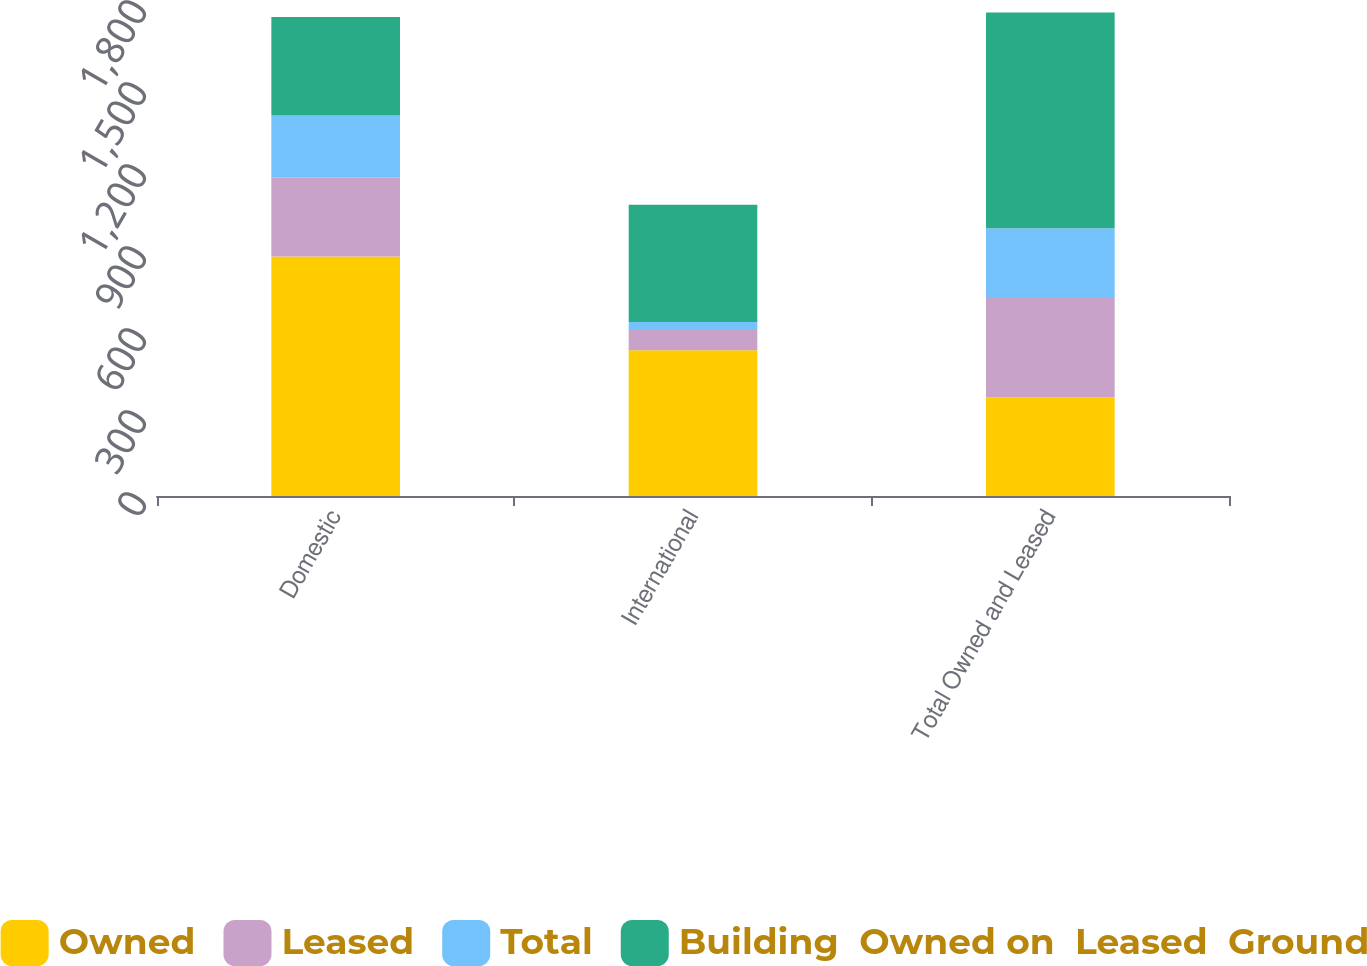Convert chart to OTSL. <chart><loc_0><loc_0><loc_500><loc_500><stacked_bar_chart><ecel><fcel>Domestic<fcel>International<fcel>Total Owned and Leased<nl><fcel>Owned<fcel>876<fcel>533<fcel>360<nl><fcel>Leased<fcel>290<fcel>78<fcel>368<nl><fcel>Total<fcel>226<fcel>26<fcel>252<nl><fcel>Building  Owned on  Leased  Ground<fcel>360<fcel>429<fcel>789<nl></chart> 